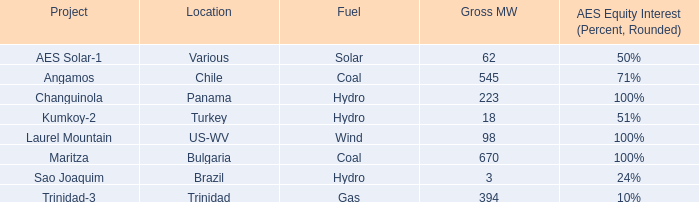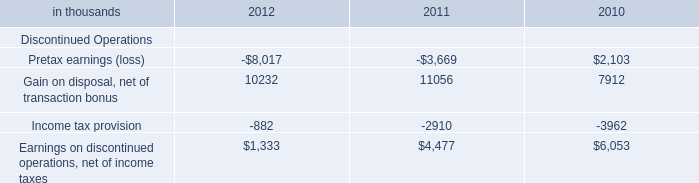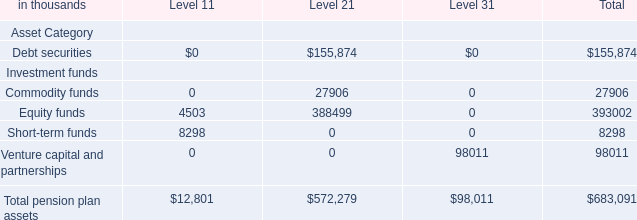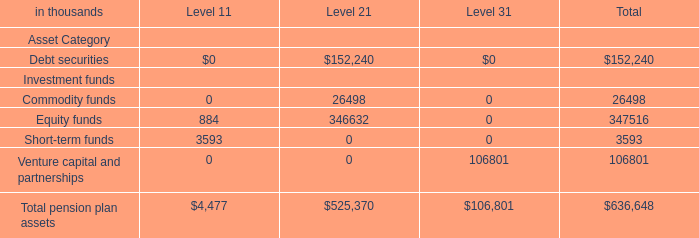What was the value of the Equity funds in the Level where the value of Debt securities is the most as As the chart 2 shows? (in thousand) 
Answer: 388499. 